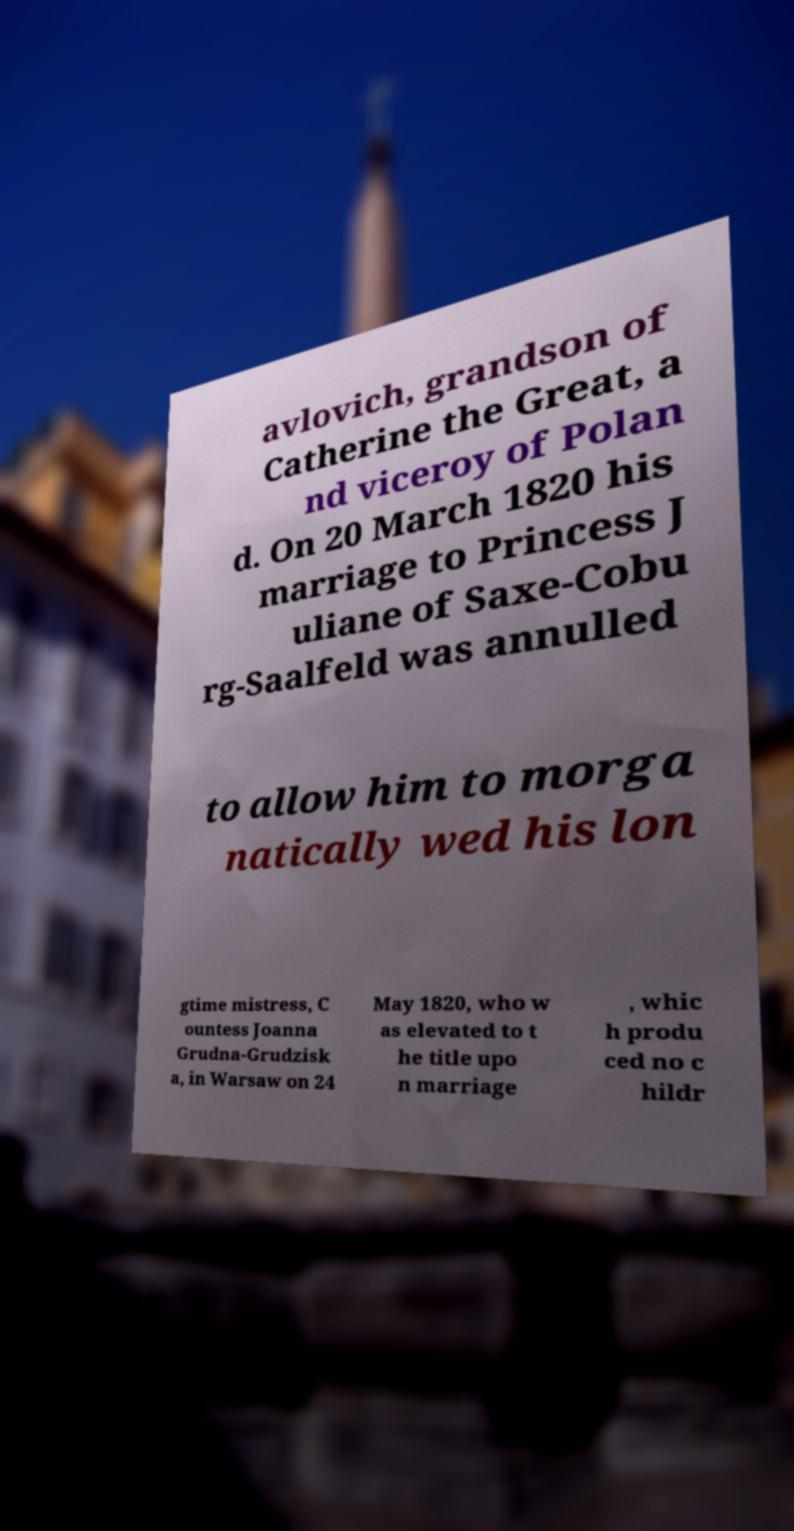I need the written content from this picture converted into text. Can you do that? avlovich, grandson of Catherine the Great, a nd viceroy of Polan d. On 20 March 1820 his marriage to Princess J uliane of Saxe-Cobu rg-Saalfeld was annulled to allow him to morga natically wed his lon gtime mistress, C ountess Joanna Grudna-Grudzisk a, in Warsaw on 24 May 1820, who w as elevated to t he title upo n marriage , whic h produ ced no c hildr 